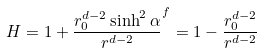<formula> <loc_0><loc_0><loc_500><loc_500>H = 1 + \frac { r _ { 0 } ^ { d - 2 } \sinh ^ { 2 } \alpha } { r ^ { d - 2 } } ^ { f } = 1 - \frac { r _ { 0 } ^ { d - 2 } } { r ^ { d - 2 } }</formula> 